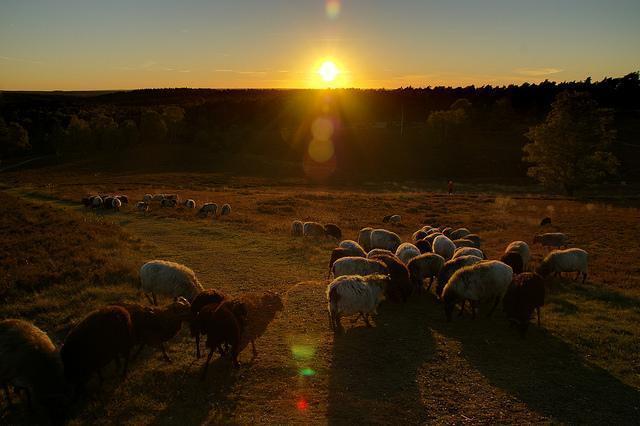How many sheep are visible?
Give a very brief answer. 8. How many men are wearing a striped shirt?
Give a very brief answer. 0. 